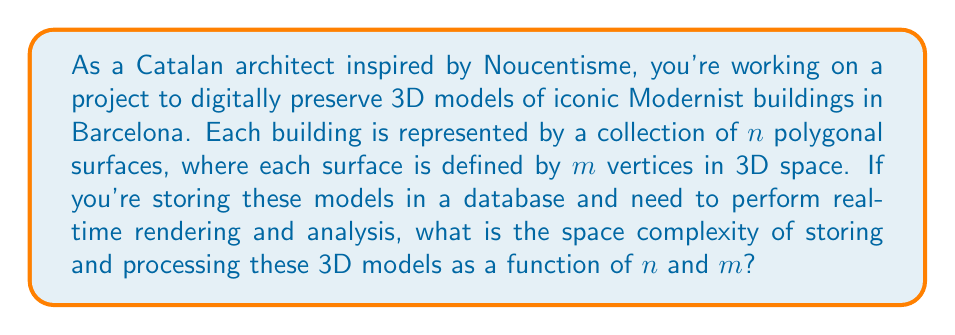Show me your answer to this math problem. To determine the space complexity, let's break down the problem step-by-step:

1. Representation of vertices:
   - Each vertex is represented by three coordinates (x, y, z) in 3D space.
   - Assuming each coordinate is stored as a floating-point number, it requires constant space.
   - For each vertex: $O(1)$ space

2. Representation of a single polygonal surface:
   - Each surface is defined by $m$ vertices.
   - Space required for one surface: $O(m)$

3. Representation of a complete building:
   - Each building consists of $n$ polygonal surfaces.
   - Space required for one building: $O(n \cdot m)$

4. Processing requirements:
   - For real-time rendering and analysis, we might need additional data structures:
     a) Normal vectors for each surface: $O(n)$
     b) Adjacency information between surfaces: $O(n^2)$ in the worst case
     c) Bounding volume hierarchy for efficient rendering: $O(n \log n)$

5. Total space complexity:
   - Combining the storage and processing requirements:
     $O(n \cdot m) + O(n) + O(n^2) + O(n \log n)$
   - The dominant term in this expression is $O(n^2)$, assuming $n > m$

Therefore, the overall space complexity for storing and processing the 3D models is $O(n^2)$, where $n$ is the number of polygonal surfaces in each building model.
Answer: The space complexity of storing and processing 3D models of Catalan Modernist buildings is $O(n^2)$, where $n$ is the number of polygonal surfaces in each building model. 